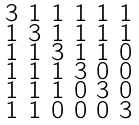Convert formula to latex. <formula><loc_0><loc_0><loc_500><loc_500>\begin{smallmatrix} 3 & 1 & 1 & 1 & 1 & 1 \\ 1 & 3 & 1 & 1 & 1 & 1 \\ 1 & 1 & 3 & 1 & 1 & 0 \\ 1 & 1 & 1 & 3 & 0 & 0 \\ 1 & 1 & 1 & 0 & 3 & 0 \\ 1 & 1 & 0 & 0 & 0 & 3 \end{smallmatrix}</formula> 